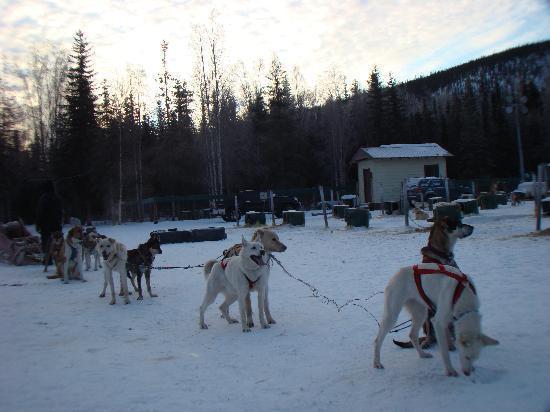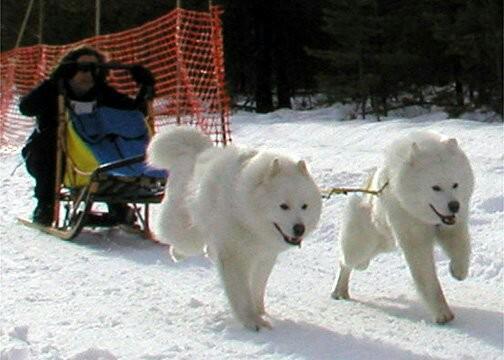The first image is the image on the left, the second image is the image on the right. For the images displayed, is the sentence "In one image, sled dogs are standing at their base camp, and in the second image, they are running to pull a sled for a driver." factually correct? Answer yes or no. Yes. The first image is the image on the left, the second image is the image on the right. Assess this claim about the two images: "One image shows a dog team running forward toward the right, and the other image includes box-shaped doghouses along the horizon in front of evergreens and tall hills.". Correct or not? Answer yes or no. Yes. 